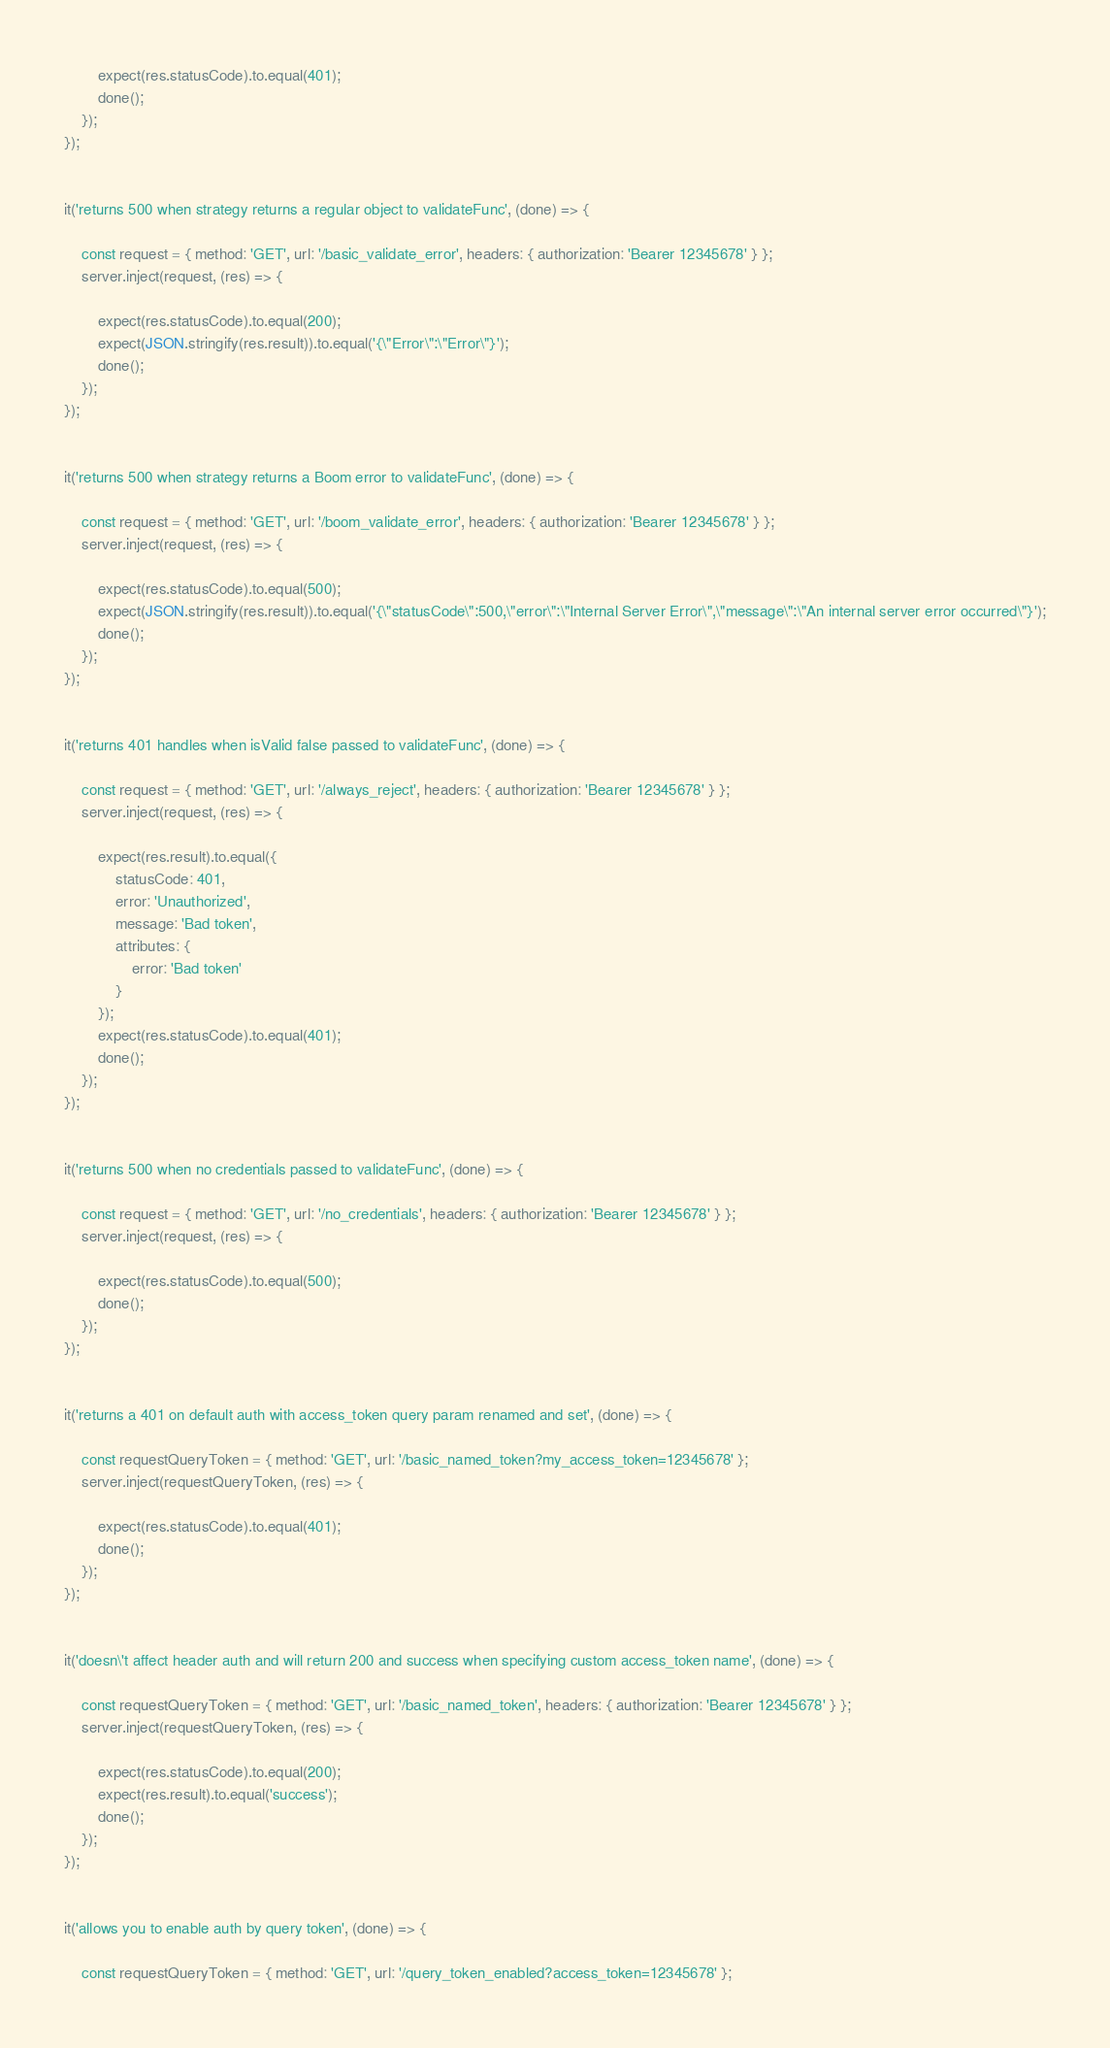<code> <loc_0><loc_0><loc_500><loc_500><_JavaScript_>
        expect(res.statusCode).to.equal(401);
        done();
    });
});


it('returns 500 when strategy returns a regular object to validateFunc', (done) => {

    const request = { method: 'GET', url: '/basic_validate_error', headers: { authorization: 'Bearer 12345678' } };
    server.inject(request, (res) => {

        expect(res.statusCode).to.equal(200);
        expect(JSON.stringify(res.result)).to.equal('{\"Error\":\"Error\"}');
        done();
    });
});


it('returns 500 when strategy returns a Boom error to validateFunc', (done) => {

    const request = { method: 'GET', url: '/boom_validate_error', headers: { authorization: 'Bearer 12345678' } };
    server.inject(request, (res) => {

        expect(res.statusCode).to.equal(500);
        expect(JSON.stringify(res.result)).to.equal('{\"statusCode\":500,\"error\":\"Internal Server Error\",\"message\":\"An internal server error occurred\"}');
        done();
    });
});


it('returns 401 handles when isValid false passed to validateFunc', (done) => {

    const request = { method: 'GET', url: '/always_reject', headers: { authorization: 'Bearer 12345678' } };
    server.inject(request, (res) => {

        expect(res.result).to.equal({
            statusCode: 401,
            error: 'Unauthorized',
            message: 'Bad token',
            attributes: {
                error: 'Bad token'
            }
        });
        expect(res.statusCode).to.equal(401);
        done();
    });
});


it('returns 500 when no credentials passed to validateFunc', (done) => {

    const request = { method: 'GET', url: '/no_credentials', headers: { authorization: 'Bearer 12345678' } };
    server.inject(request, (res) => {

        expect(res.statusCode).to.equal(500);
        done();
    });
});


it('returns a 401 on default auth with access_token query param renamed and set', (done) => {

    const requestQueryToken = { method: 'GET', url: '/basic_named_token?my_access_token=12345678' };
    server.inject(requestQueryToken, (res) => {

        expect(res.statusCode).to.equal(401);
        done();
    });
});


it('doesn\'t affect header auth and will return 200 and success when specifying custom access_token name', (done) => {

    const requestQueryToken = { method: 'GET', url: '/basic_named_token', headers: { authorization: 'Bearer 12345678' } };
    server.inject(requestQueryToken, (res) => {

        expect(res.statusCode).to.equal(200);
        expect(res.result).to.equal('success');
        done();
    });
});


it('allows you to enable auth by query token', (done) => {

    const requestQueryToken = { method: 'GET', url: '/query_token_enabled?access_token=12345678' };</code> 